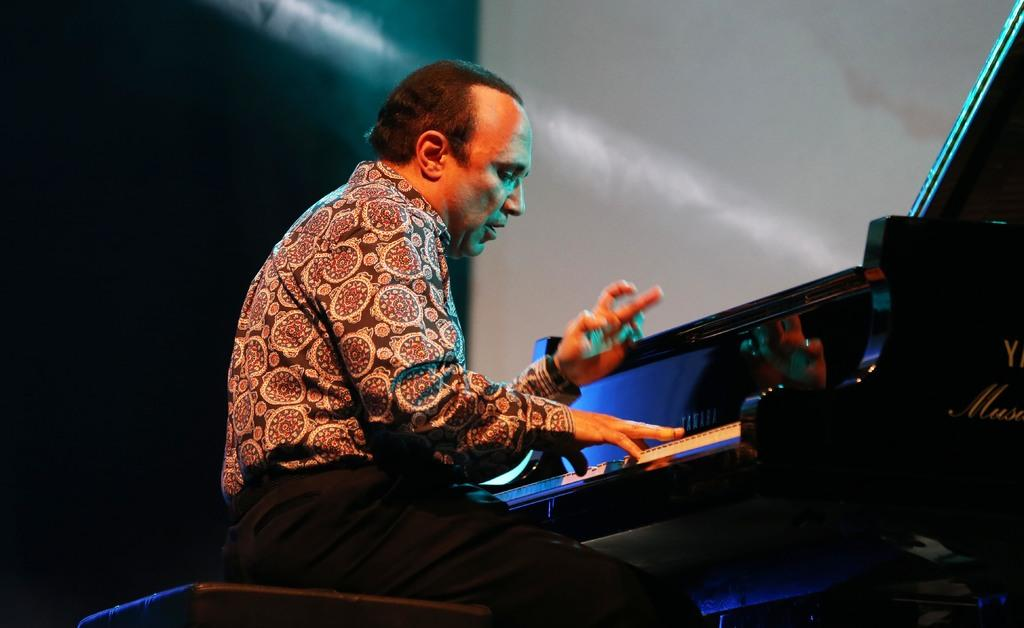What is the man in the image doing? The man is playing a keyboard. Where is the keyboard located in the image? The keyboard is on the right side of the image. What can be seen in the background of the image? There is a wall in the background of the image. What type of copper edge can be seen on the keyboard in the image? There is no mention of copper or an edge on the keyboard in the image. 